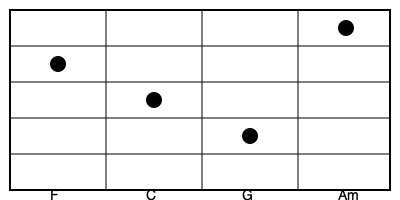Identify the famous Beatles song that uses the chord progression shown in the guitar fretboard diagram above, and explain its significance in the context of the band's musical evolution. To identify this Beatles song and understand its significance, let's break down the process:

1. Chord Progression Analysis:
   The fretboard diagram shows the chord progression: F - C - G - Am

2. Song Identification:
   This chord progression is the basis for the verse of "Let It Be," one of the Beatles' most iconic songs.

3. Musical Context:
   - "Let It Be" was released in 1970 as part of the album of the same name.
   - It was one of the last songs recorded by the Beatles before their breakup.

4. Compositional Significance:
   - The chord progression (F - C - G - Am) is a variation of the classic I - V - vi - IV progression, which is common in pop music.
   - The use of F as the starting chord (instead of C) gives the song a more somber, reflective quality.

5. Lyrical and Thematic Importance:
   - The song's message of hope and perseverance reflects the band's state during their final days together.
   - It showcases Paul McCartney's ability to write emotionally resonant, anthemic ballads.

6. Musical Evolution:
   - "Let It Be" represents a return to a more straightforward, piano-driven style after the band's psychedelic period.
   - It demonstrates the Beatles' ability to create timeless, universal songs even as they were nearing the end of their time together.

7. Legacy:
   - The song has become one of the Beatles' most enduring and widely covered tracks.
   - Its simple yet powerful chord progression has influenced countless musicians and songwriters.
Answer: "Let It Be" 